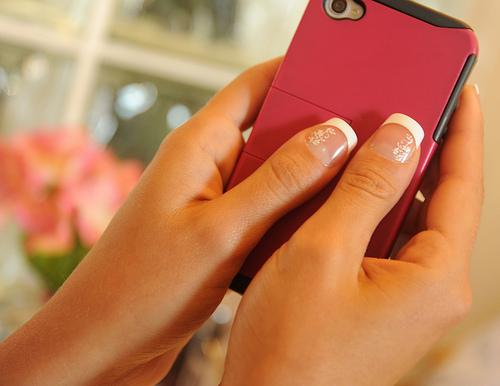How many different fingers can you identify in the image? In the image, you can identify five different fingers. Analyze and describe the interaction between objects in the image. A person is holding a phone with a pink case, focusing the phone camera on their hand which displays their french-tipped nails and fingers. Assess the quality of the image in terms of clarity and composition. The image appears to be of good quality with clear objects and well-defined composition. What's the most interesting feature about the person's nails in the picture? The most interesting feature about the person's nails is the french tip design. Count the number of phones in the image. There is one phone in the image. Briefly describe the general theme of the image. The image depicts a person's hand holding a pink phone, showing their french-tipped nails and fingers. Determine the sentiment or mood of the image. The sentiment of the image is neutral, showing a person's hand holding a phone, focusing on their nails and fingers. What kind of camera is visible in the image? A phone camera is visible in the image. Can you tell the color of the phone case in the image? The phone case in the image is pink. What is the primary device being held in the image? The primary device being held in the image is a phone. Can you see a cat sitting on the hand? Look for a small brown cat on the person's hand. No, it's not mentioned in the image. Observe a small dog looking up at the person holding the phone. The dog has a black and white coat and a curious expression. No captions mention any animals, specifically dogs, in the image. The focus is on the person, their hands, and the phone they are holding, making the dog non-existent in the image. What kind of coffee cup is in the lower left corner of the picture? It's a white one with a blue pattern. There are no mentions of coffee cups or objects in the lower left corner in any of the captions, making this instruction false. Do you notice a painting hanging on a wall in the background? It features an abstract design with blue and green colors. There is only one mention of a drawing in the captions, and it is unrelated to a painting, wall, or any kind of background. The rest of the image focuses on the person and their interactions with the phone. Find the red balloon tied up behind those flowers. It's quite round and shiny. The only object mentioned related to flowers is 'these are flowers,' and there is no mention of a balloon, red or otherwise, in any caption.  